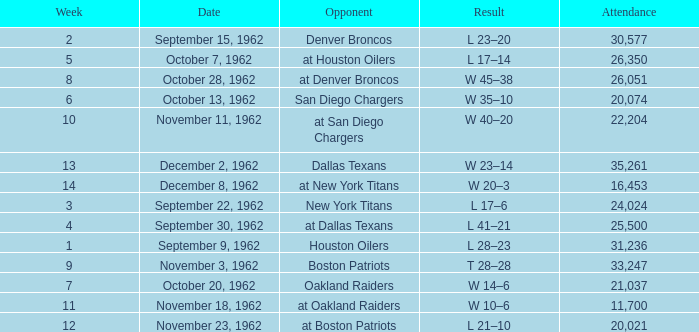What week was the attendance smaller than 22,204 on December 8, 1962? 14.0. 